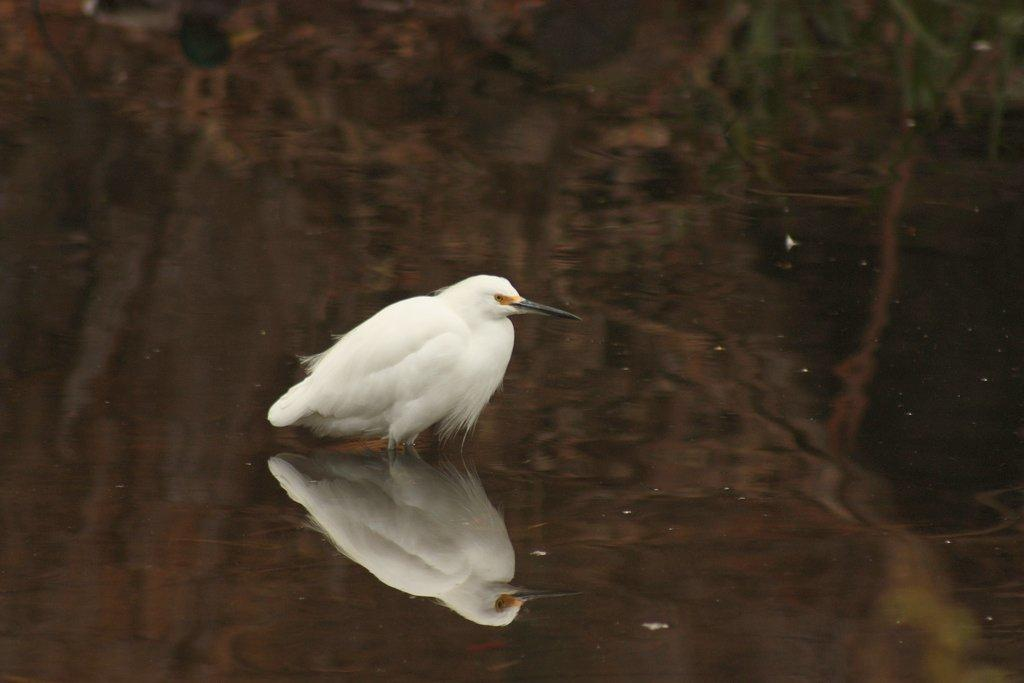What is the main subject of the picture? There is a bird in the center of the picture. What is the setting of the picture? The picture contains water. What can be observed in the water? The water reflects the trees. What type of shirt is the bird wearing in the picture? Birds do not wear shirts, so this detail cannot be observed in the image. 